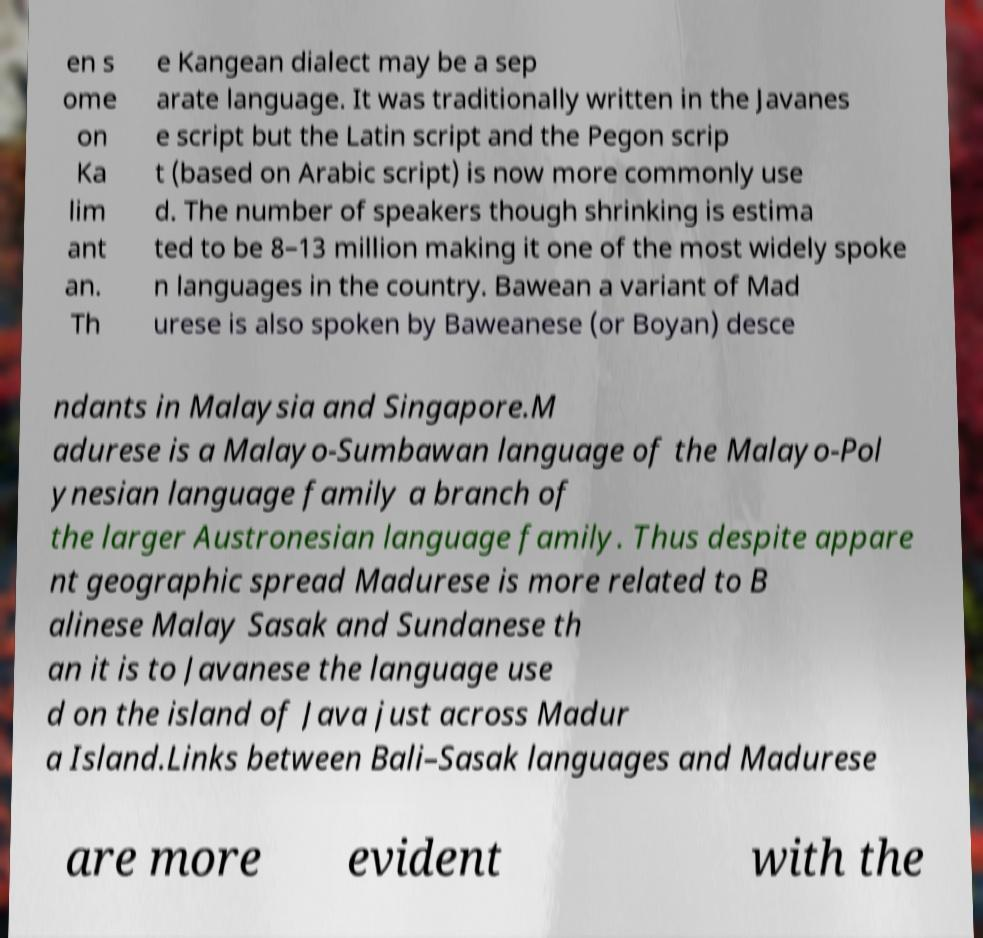For documentation purposes, I need the text within this image transcribed. Could you provide that? en s ome on Ka lim ant an. Th e Kangean dialect may be a sep arate language. It was traditionally written in the Javanes e script but the Latin script and the Pegon scrip t (based on Arabic script) is now more commonly use d. The number of speakers though shrinking is estima ted to be 8–13 million making it one of the most widely spoke n languages in the country. Bawean a variant of Mad urese is also spoken by Baweanese (or Boyan) desce ndants in Malaysia and Singapore.M adurese is a Malayo-Sumbawan language of the Malayo-Pol ynesian language family a branch of the larger Austronesian language family. Thus despite appare nt geographic spread Madurese is more related to B alinese Malay Sasak and Sundanese th an it is to Javanese the language use d on the island of Java just across Madur a Island.Links between Bali–Sasak languages and Madurese are more evident with the 